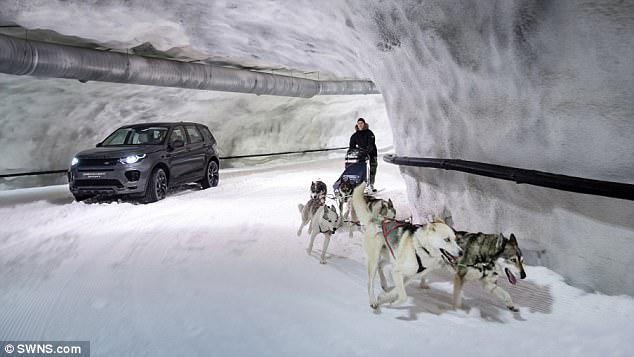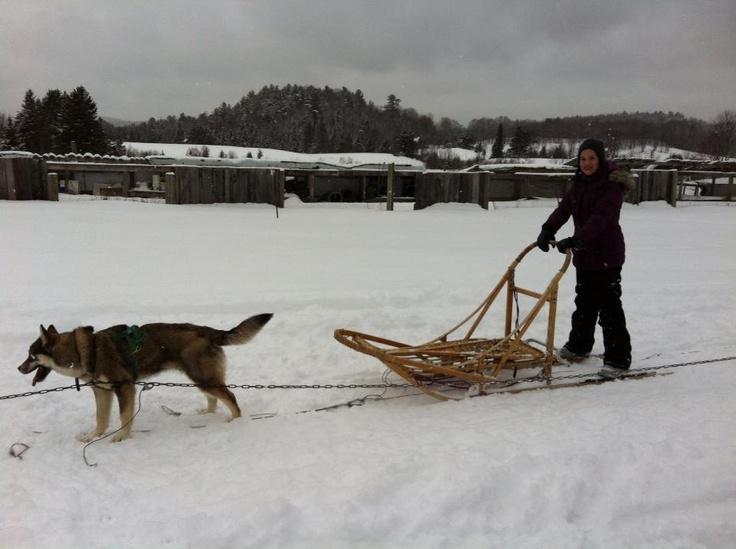The first image is the image on the left, the second image is the image on the right. For the images shown, is this caption "In the left image there are sled dogs up close pulling straight ahead towards the camera." true? Answer yes or no. No. 